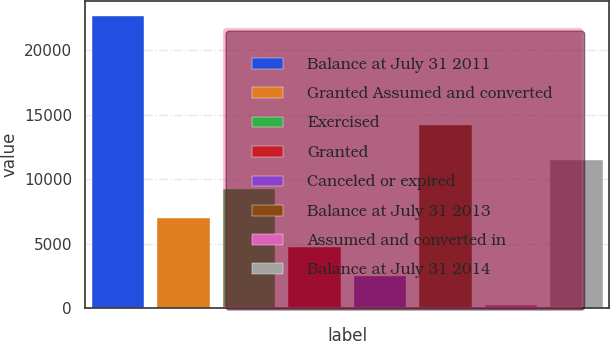Convert chart to OTSL. <chart><loc_0><loc_0><loc_500><loc_500><bar_chart><fcel>Balance at July 31 2011<fcel>Granted Assumed and converted<fcel>Exercised<fcel>Granted<fcel>Canceled or expired<fcel>Balance at July 31 2013<fcel>Assumed and converted in<fcel>Balance at July 31 2014<nl><fcel>22679<fcel>6986.4<fcel>9228.2<fcel>4744.6<fcel>2502.8<fcel>14206<fcel>261<fcel>11470<nl></chart> 